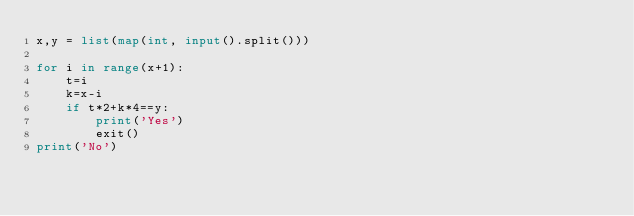Convert code to text. <code><loc_0><loc_0><loc_500><loc_500><_Python_>x,y = list(map(int, input().split()))

for i in range(x+1):
    t=i
    k=x-i
    if t*2+k*4==y:
        print('Yes')
        exit()
print('No')
</code> 